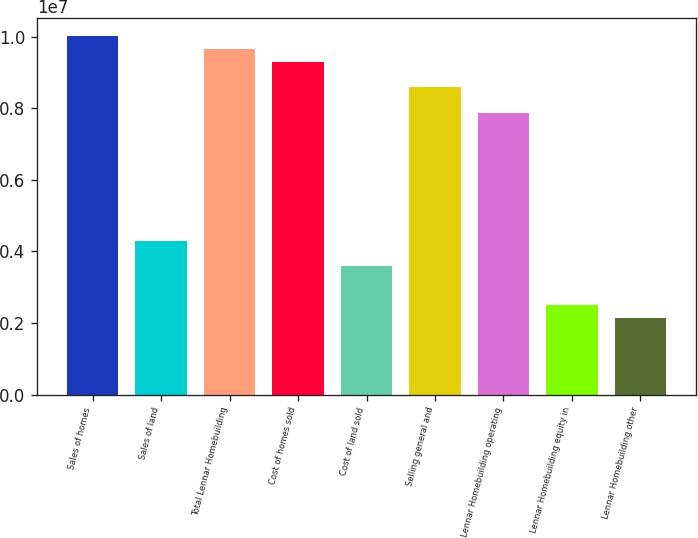<chart> <loc_0><loc_0><loc_500><loc_500><bar_chart><fcel>Sales of homes<fcel>Sales of land<fcel>Total Lennar Homebuilding<fcel>Cost of homes sold<fcel>Cost of land sold<fcel>Selling general and<fcel>Lennar Homebuilding operating<fcel>Lennar Homebuilding equity in<fcel>Lennar Homebuilding other<nl><fcel>1.00274e+07<fcel>4.29748e+06<fcel>9.66931e+06<fcel>9.31119e+06<fcel>3.58123e+06<fcel>8.59494e+06<fcel>7.8787e+06<fcel>2.50687e+06<fcel>2.14874e+06<nl></chart> 